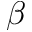<formula> <loc_0><loc_0><loc_500><loc_500>\beta</formula> 